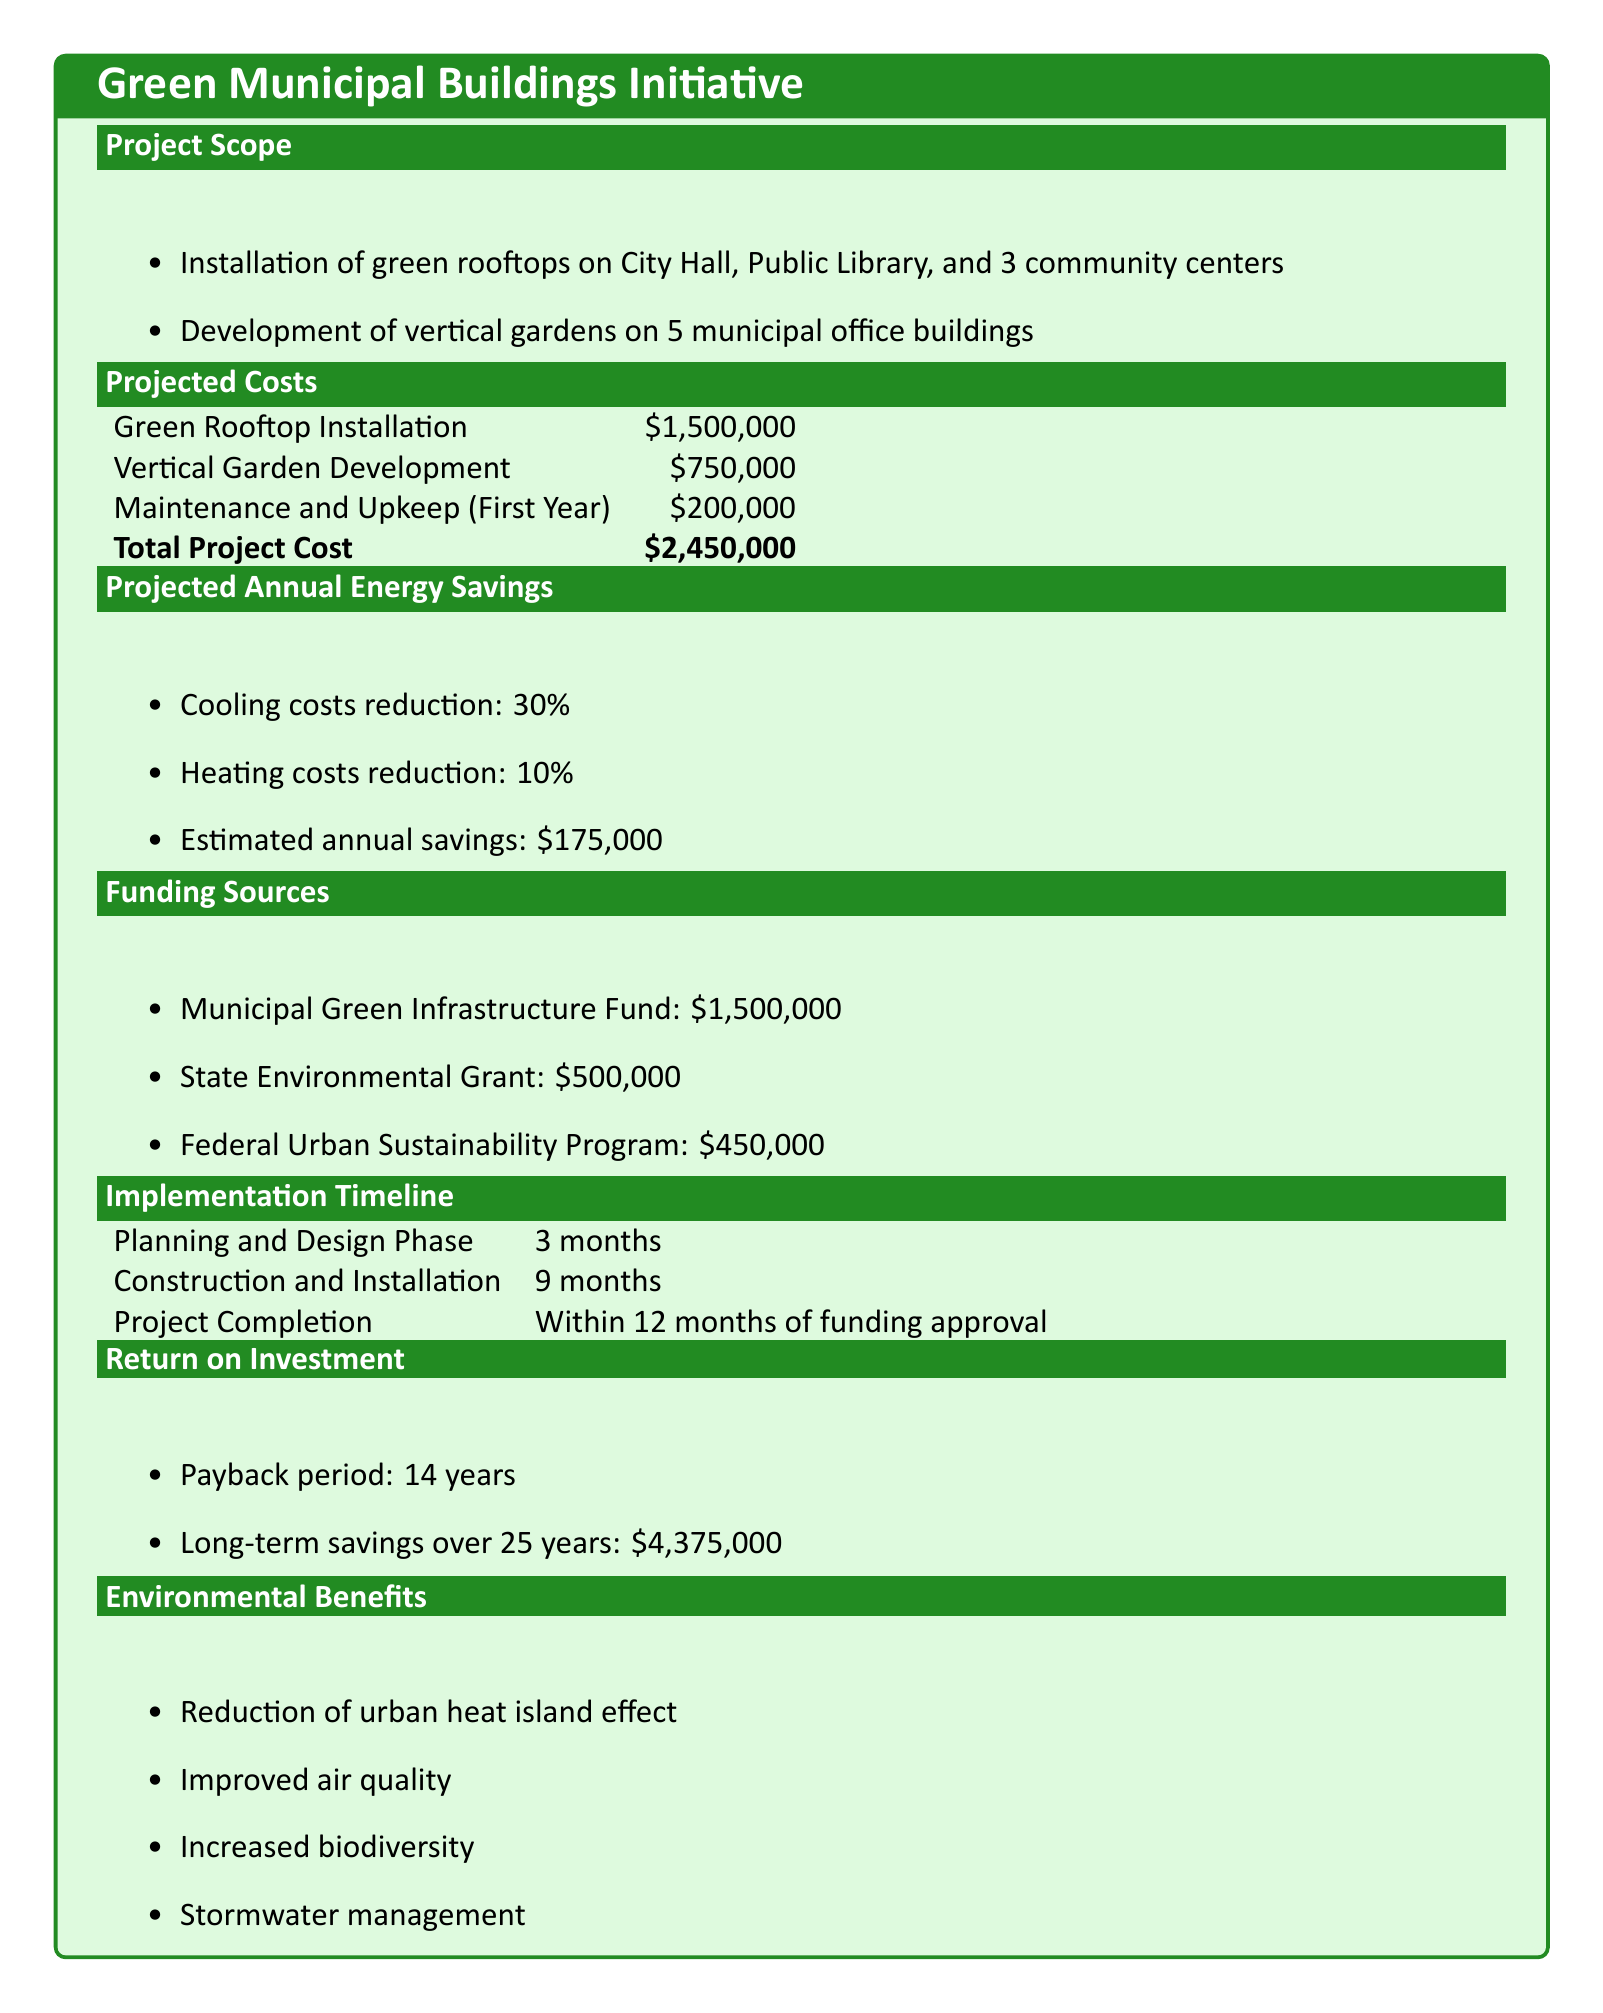What is the total project cost? The total project cost is the sum of the costs for green rooftop installation, vertical garden development, and maintenance, which is $1,500,000 + $750,000 + $200,000 = $2,450,000.
Answer: $2,450,000 What is the estimated annual savings? The estimated annual savings from reduced cooling and heating costs is explicitly stated in the document.
Answer: $175,000 How many municipal office buildings will receive vertical gardens? The document specifies the number of municipal office buildings to receive vertical gardens directly in the project scope.
Answer: 5 What is the payback period for this project? The payback period is provided in the return on investment section of the document.
Answer: 14 years What is the projected reduction in cooling costs? The document states the percentage reduction in cooling costs as a specific number.
Answer: 30% What will the maintenance and upkeep cost in the first year? The first year maintenance and upkeep cost is clearly outlined in the projected costs section.
Answer: $200,000 How long is the planning and design phase? The duration of the planning and design phase is stated in the implementation timeline section of the document.
Answer: 3 months What is one environmental benefit mentioned in the document? The document lists several environmental benefits, and any of them can be referenced as an answer.
Answer: Improved air quality 